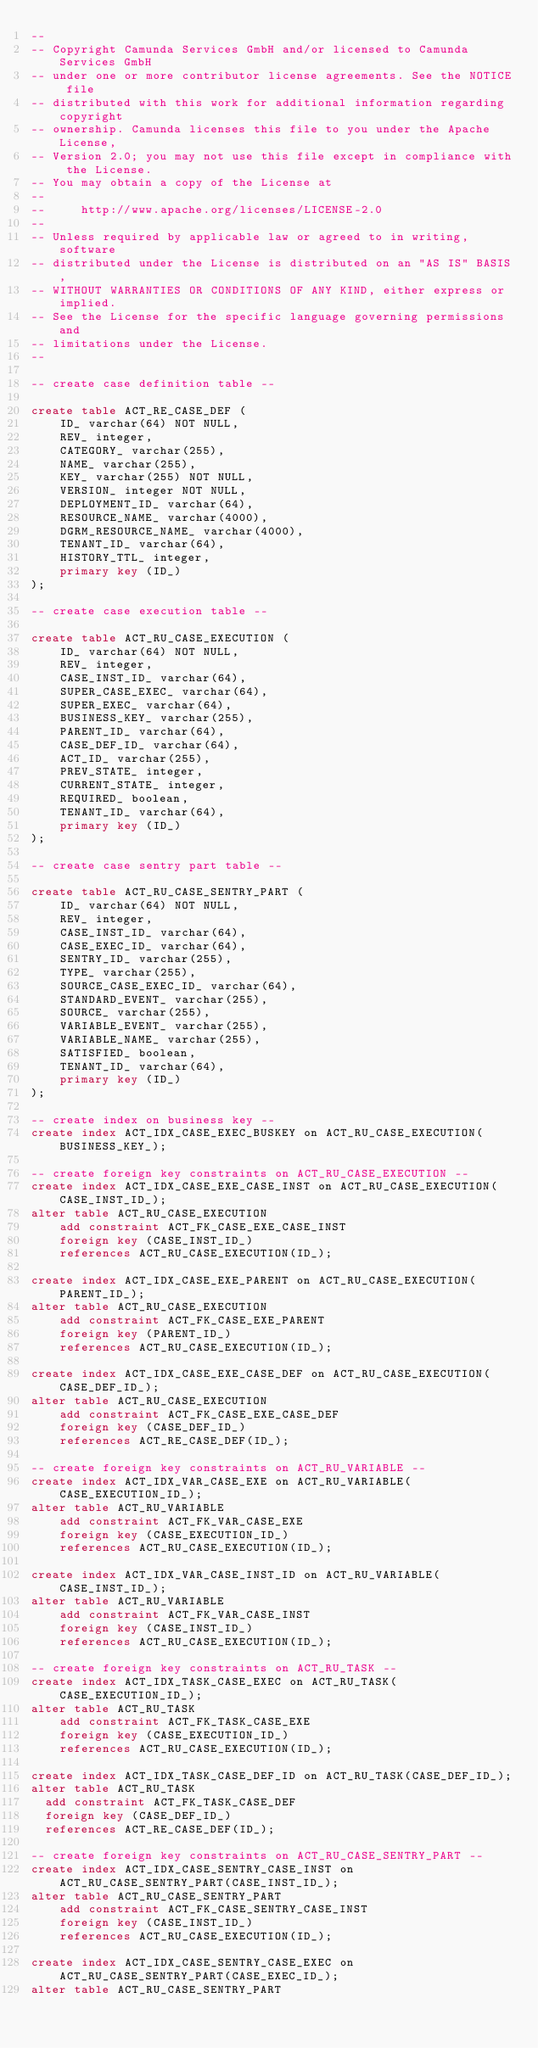Convert code to text. <code><loc_0><loc_0><loc_500><loc_500><_SQL_>--
-- Copyright Camunda Services GmbH and/or licensed to Camunda Services GmbH
-- under one or more contributor license agreements. See the NOTICE file
-- distributed with this work for additional information regarding copyright
-- ownership. Camunda licenses this file to you under the Apache License,
-- Version 2.0; you may not use this file except in compliance with the License.
-- You may obtain a copy of the License at
--
--     http://www.apache.org/licenses/LICENSE-2.0
--
-- Unless required by applicable law or agreed to in writing, software
-- distributed under the License is distributed on an "AS IS" BASIS,
-- WITHOUT WARRANTIES OR CONDITIONS OF ANY KIND, either express or implied.
-- See the License for the specific language governing permissions and
-- limitations under the License.
--

-- create case definition table --

create table ACT_RE_CASE_DEF (
    ID_ varchar(64) NOT NULL,
    REV_ integer,
    CATEGORY_ varchar(255),
    NAME_ varchar(255),
    KEY_ varchar(255) NOT NULL,
    VERSION_ integer NOT NULL,
    DEPLOYMENT_ID_ varchar(64),
    RESOURCE_NAME_ varchar(4000),
    DGRM_RESOURCE_NAME_ varchar(4000),
    TENANT_ID_ varchar(64),
    HISTORY_TTL_ integer,
    primary key (ID_)
);

-- create case execution table --

create table ACT_RU_CASE_EXECUTION (
    ID_ varchar(64) NOT NULL,
    REV_ integer,
    CASE_INST_ID_ varchar(64),
    SUPER_CASE_EXEC_ varchar(64),
    SUPER_EXEC_ varchar(64),
    BUSINESS_KEY_ varchar(255),
    PARENT_ID_ varchar(64),
    CASE_DEF_ID_ varchar(64),
    ACT_ID_ varchar(255),
    PREV_STATE_ integer,
    CURRENT_STATE_ integer,
    REQUIRED_ boolean,
    TENANT_ID_ varchar(64),
    primary key (ID_)
);

-- create case sentry part table --

create table ACT_RU_CASE_SENTRY_PART (
    ID_ varchar(64) NOT NULL,
    REV_ integer,
    CASE_INST_ID_ varchar(64),
    CASE_EXEC_ID_ varchar(64),
    SENTRY_ID_ varchar(255),
    TYPE_ varchar(255),
    SOURCE_CASE_EXEC_ID_ varchar(64),
    STANDARD_EVENT_ varchar(255),
    SOURCE_ varchar(255),
    VARIABLE_EVENT_ varchar(255),
    VARIABLE_NAME_ varchar(255),
    SATISFIED_ boolean,
    TENANT_ID_ varchar(64),
    primary key (ID_)
);

-- create index on business key --
create index ACT_IDX_CASE_EXEC_BUSKEY on ACT_RU_CASE_EXECUTION(BUSINESS_KEY_);

-- create foreign key constraints on ACT_RU_CASE_EXECUTION --
create index ACT_IDX_CASE_EXE_CASE_INST on ACT_RU_CASE_EXECUTION(CASE_INST_ID_);
alter table ACT_RU_CASE_EXECUTION
    add constraint ACT_FK_CASE_EXE_CASE_INST
    foreign key (CASE_INST_ID_)
    references ACT_RU_CASE_EXECUTION(ID_);

create index ACT_IDX_CASE_EXE_PARENT on ACT_RU_CASE_EXECUTION(PARENT_ID_);
alter table ACT_RU_CASE_EXECUTION
    add constraint ACT_FK_CASE_EXE_PARENT
    foreign key (PARENT_ID_)
    references ACT_RU_CASE_EXECUTION(ID_);

create index ACT_IDX_CASE_EXE_CASE_DEF on ACT_RU_CASE_EXECUTION(CASE_DEF_ID_);
alter table ACT_RU_CASE_EXECUTION
    add constraint ACT_FK_CASE_EXE_CASE_DEF
    foreign key (CASE_DEF_ID_)
    references ACT_RE_CASE_DEF(ID_);

-- create foreign key constraints on ACT_RU_VARIABLE --
create index ACT_IDX_VAR_CASE_EXE on ACT_RU_VARIABLE(CASE_EXECUTION_ID_);
alter table ACT_RU_VARIABLE
    add constraint ACT_FK_VAR_CASE_EXE
    foreign key (CASE_EXECUTION_ID_)
    references ACT_RU_CASE_EXECUTION(ID_);

create index ACT_IDX_VAR_CASE_INST_ID on ACT_RU_VARIABLE(CASE_INST_ID_);
alter table ACT_RU_VARIABLE
    add constraint ACT_FK_VAR_CASE_INST
    foreign key (CASE_INST_ID_)
    references ACT_RU_CASE_EXECUTION(ID_);

-- create foreign key constraints on ACT_RU_TASK --
create index ACT_IDX_TASK_CASE_EXEC on ACT_RU_TASK(CASE_EXECUTION_ID_);
alter table ACT_RU_TASK
    add constraint ACT_FK_TASK_CASE_EXE
    foreign key (CASE_EXECUTION_ID_)
    references ACT_RU_CASE_EXECUTION(ID_);

create index ACT_IDX_TASK_CASE_DEF_ID on ACT_RU_TASK(CASE_DEF_ID_);
alter table ACT_RU_TASK
  add constraint ACT_FK_TASK_CASE_DEF
  foreign key (CASE_DEF_ID_)
  references ACT_RE_CASE_DEF(ID_);

-- create foreign key constraints on ACT_RU_CASE_SENTRY_PART --
create index ACT_IDX_CASE_SENTRY_CASE_INST on ACT_RU_CASE_SENTRY_PART(CASE_INST_ID_);
alter table ACT_RU_CASE_SENTRY_PART
    add constraint ACT_FK_CASE_SENTRY_CASE_INST
    foreign key (CASE_INST_ID_)
    references ACT_RU_CASE_EXECUTION(ID_);

create index ACT_IDX_CASE_SENTRY_CASE_EXEC on ACT_RU_CASE_SENTRY_PART(CASE_EXEC_ID_);
alter table ACT_RU_CASE_SENTRY_PART</code> 